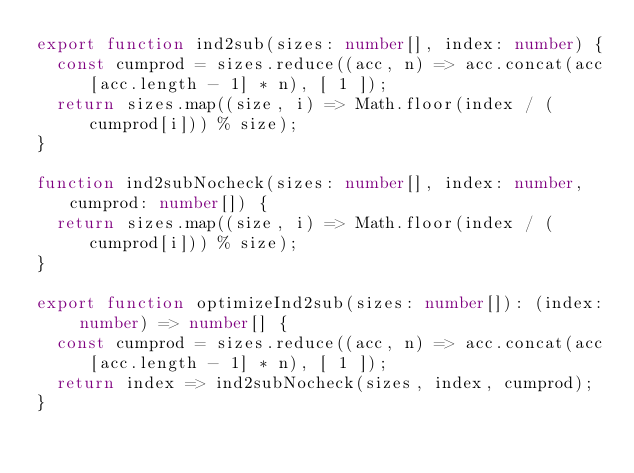<code> <loc_0><loc_0><loc_500><loc_500><_TypeScript_>export function ind2sub(sizes: number[], index: number) {
  const cumprod = sizes.reduce((acc, n) => acc.concat(acc[acc.length - 1] * n), [ 1 ]);
  return sizes.map((size, i) => Math.floor(index / (cumprod[i])) % size);
}

function ind2subNocheck(sizes: number[], index: number, cumprod: number[]) {
  return sizes.map((size, i) => Math.floor(index / (cumprod[i])) % size);
}

export function optimizeInd2sub(sizes: number[]): (index: number) => number[] {
  const cumprod = sizes.reduce((acc, n) => acc.concat(acc[acc.length - 1] * n), [ 1 ]);
  return index => ind2subNocheck(sizes, index, cumprod);
}
</code> 